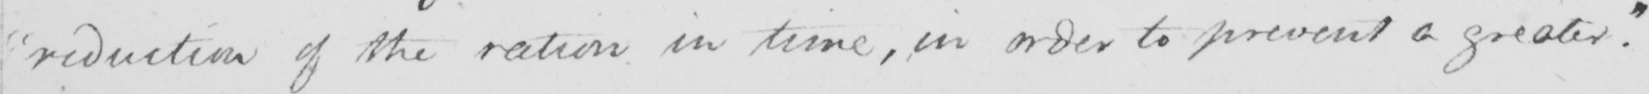What does this handwritten line say? reduction of the ration in time , in order to prevent a greater . 